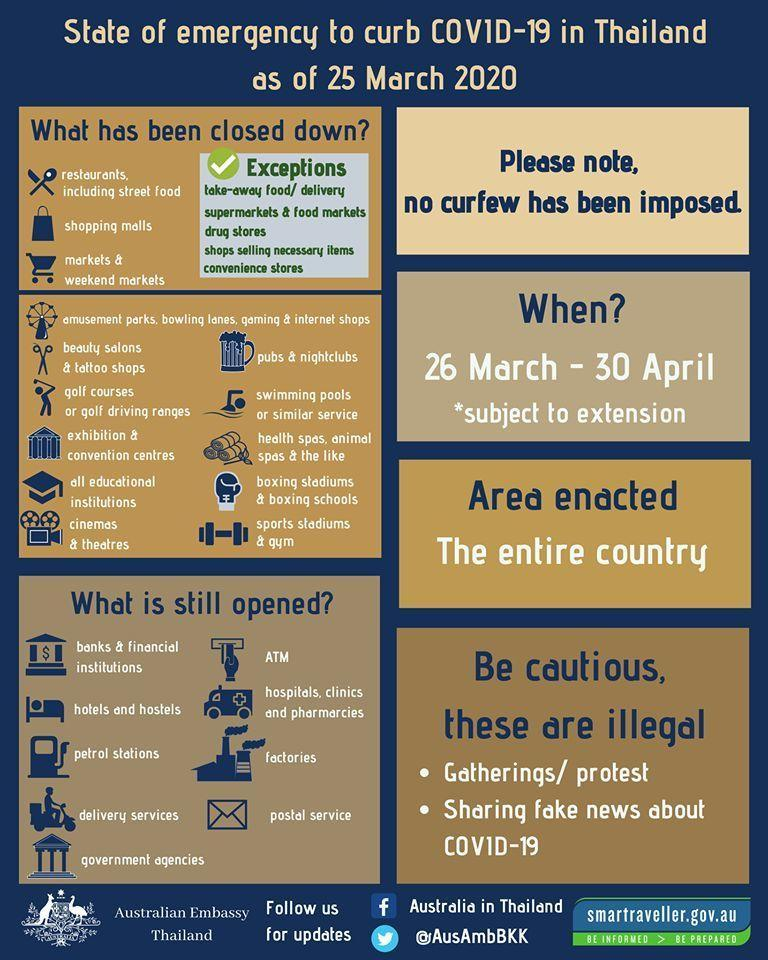What is the Twitter handle given?
Answer the question with a short phrase. @AusAmbBKK What is the Facebook profile given? Australia in Thailand 